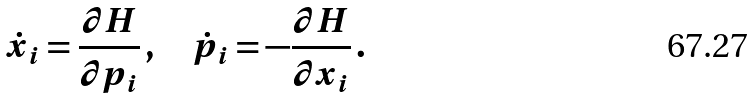<formula> <loc_0><loc_0><loc_500><loc_500>\dot { x } _ { i } = \frac { \partial H } { \partial p _ { i } } \, , \quad \dot { p } _ { i } = - \frac { \partial H } { \partial x _ { i } } \, .</formula> 